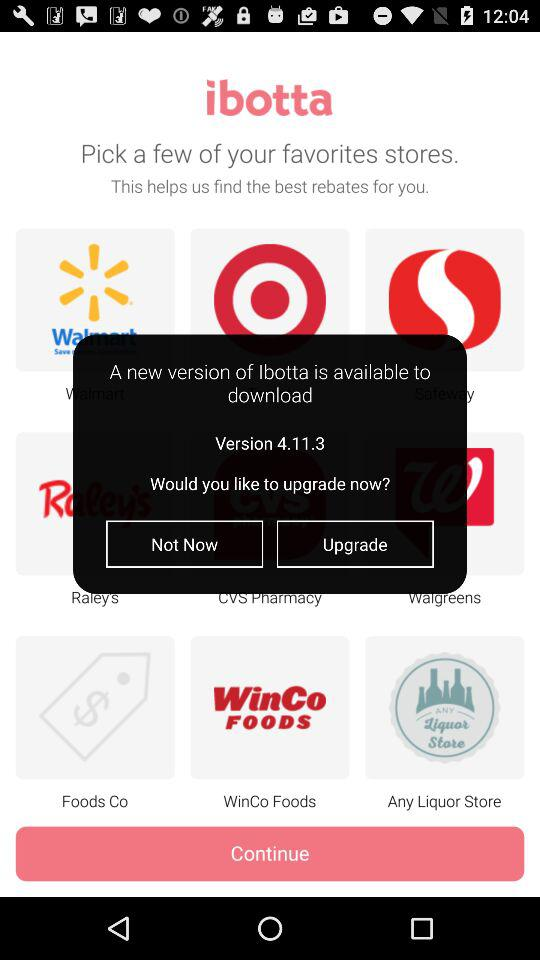What is the application name? The application name is "ibotta". 